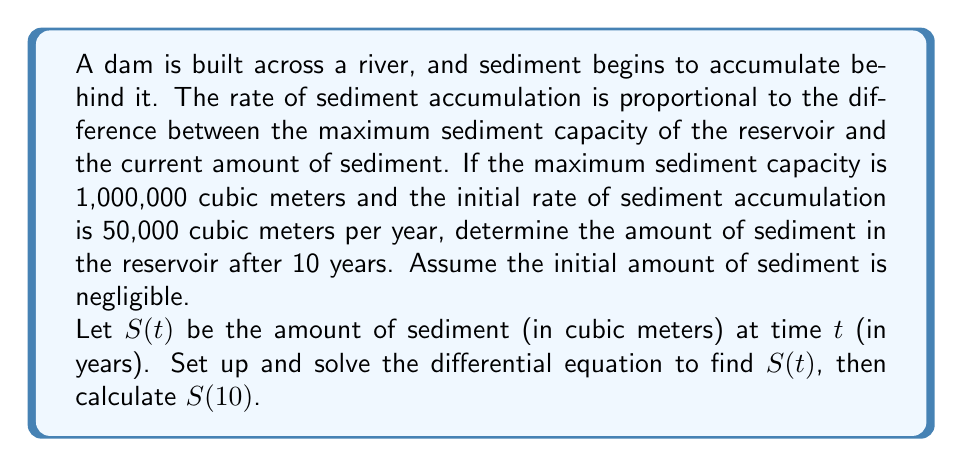Show me your answer to this math problem. Let's approach this problem step-by-step:

1) First, we need to set up the differential equation. The rate of change of sediment is proportional to the difference between the maximum capacity and the current amount:

   $$\frac{dS}{dt} = k(1000000 - S)$$

   where $k$ is the proportionality constant.

2) We're told that the initial rate is 50,000 cubic meters per year when $S$ is close to 0. So:

   $$50000 = k(1000000 - 0)$$
   $$k = \frac{50000}{1000000} = 0.05$$

3) Now our differential equation is:

   $$\frac{dS}{dt} = 0.05(1000000 - S)$$

4) This is a separable equation. Let's separate and integrate:

   $$\int \frac{dS}{1000000 - S} = \int 0.05 dt$$

5) The left side integrates to $-\ln|1000000 - S|$, so we have:

   $$-\ln|1000000 - S| = 0.05t + C$$

6) Solving for $S$:

   $$S = 1000000 - e^{-0.05t - C}$$
   $$S = 1000000 - Ae^{-0.05t}$$

   where $A = e^C$

7) To find $A$, we use the initial condition $S(0) = 0$:

   $$0 = 1000000 - A$$
   $$A = 1000000$$

8) Therefore, our solution is:

   $$S(t) = 1000000(1 - e^{-0.05t})$$

9) To find $S(10)$, we simply plug in $t = 10$:

   $$S(10) = 1000000(1 - e^{-0.05(10)})$$
   $$= 1000000(1 - e^{-0.5})$$
   $$\approx 393,469 \text{ cubic meters}$$
Answer: After 10 years, the amount of sediment in the reservoir will be approximately 393,469 cubic meters. 